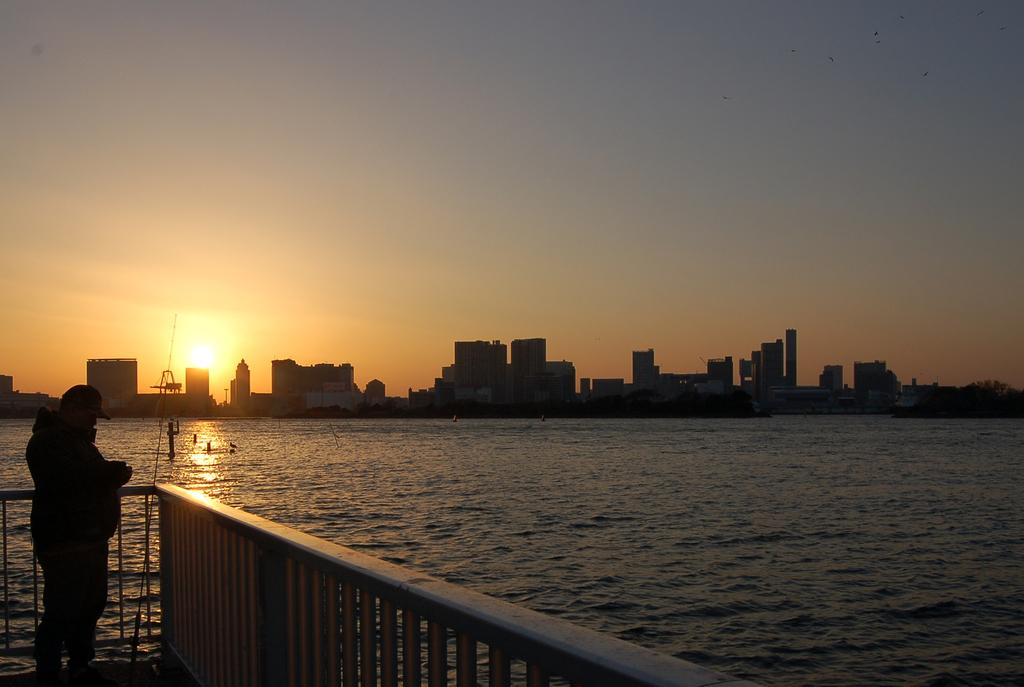What is the main subject of the image? There is a person standing in the image. What is the person wearing? The person is wearing clothes and a cap. What can be seen in the background of the image? There is a fence, water, many buildings, and the sky visible in the image. Can you describe the sky in the image? The sky is visible in the image, and the sun is visible in the sky. There are also birds flying in the sky. What type of liquid is leaking from the hole in the person's shirt in the image? There is no hole or liquid present in the image; the person is wearing a cap and clothes without any visible damage or leakage. 